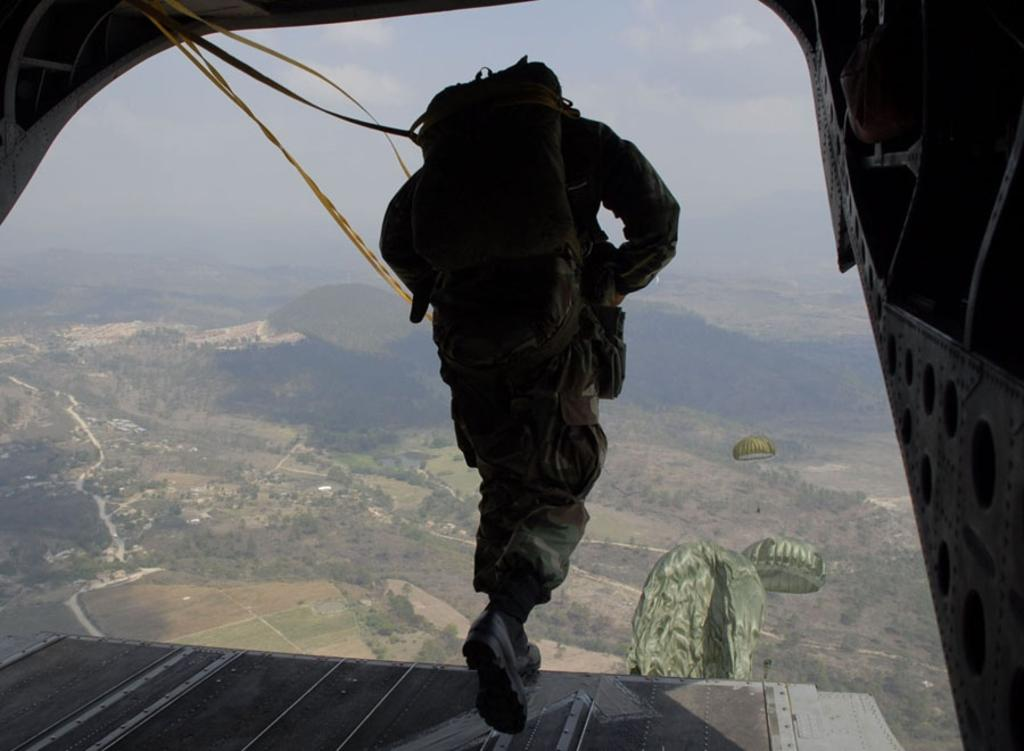What is the main subject of the image? There is a person in the image. What type of clothing is the person wearing? The person is wearing a military dress. What is the person carrying on his back? The person is carrying a bag on his back. What can be seen in front of the person? There are parachutes in front of the person. What is visible in the background of the image? There are trees in the background of the image. What type of meat is hanging from the shelf in the image? There is no shelf or meat present in the image. Is the person playing baseball in the image? There is no indication of a baseball or any baseball-related activity in the image. 